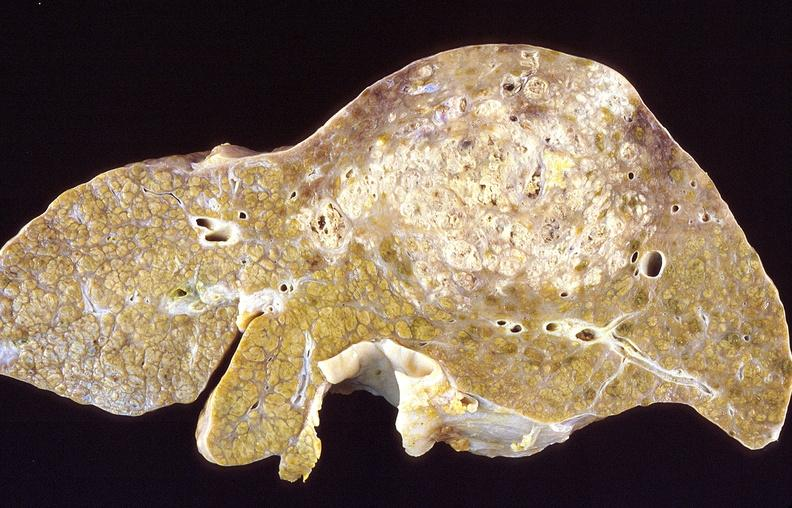s histiocyte present?
Answer the question using a single word or phrase. No 